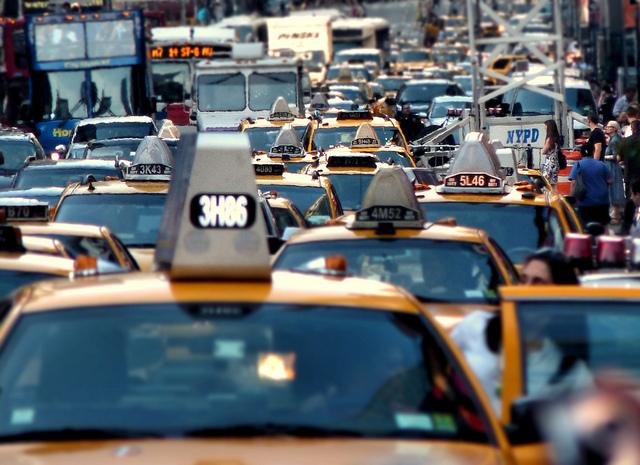How many taxis are there?
Keep it brief. 12. Is this a crowded street?
Short answer required. Yes. What is the number and letter on top of the cab roof?
Give a very brief answer. 3h86. 